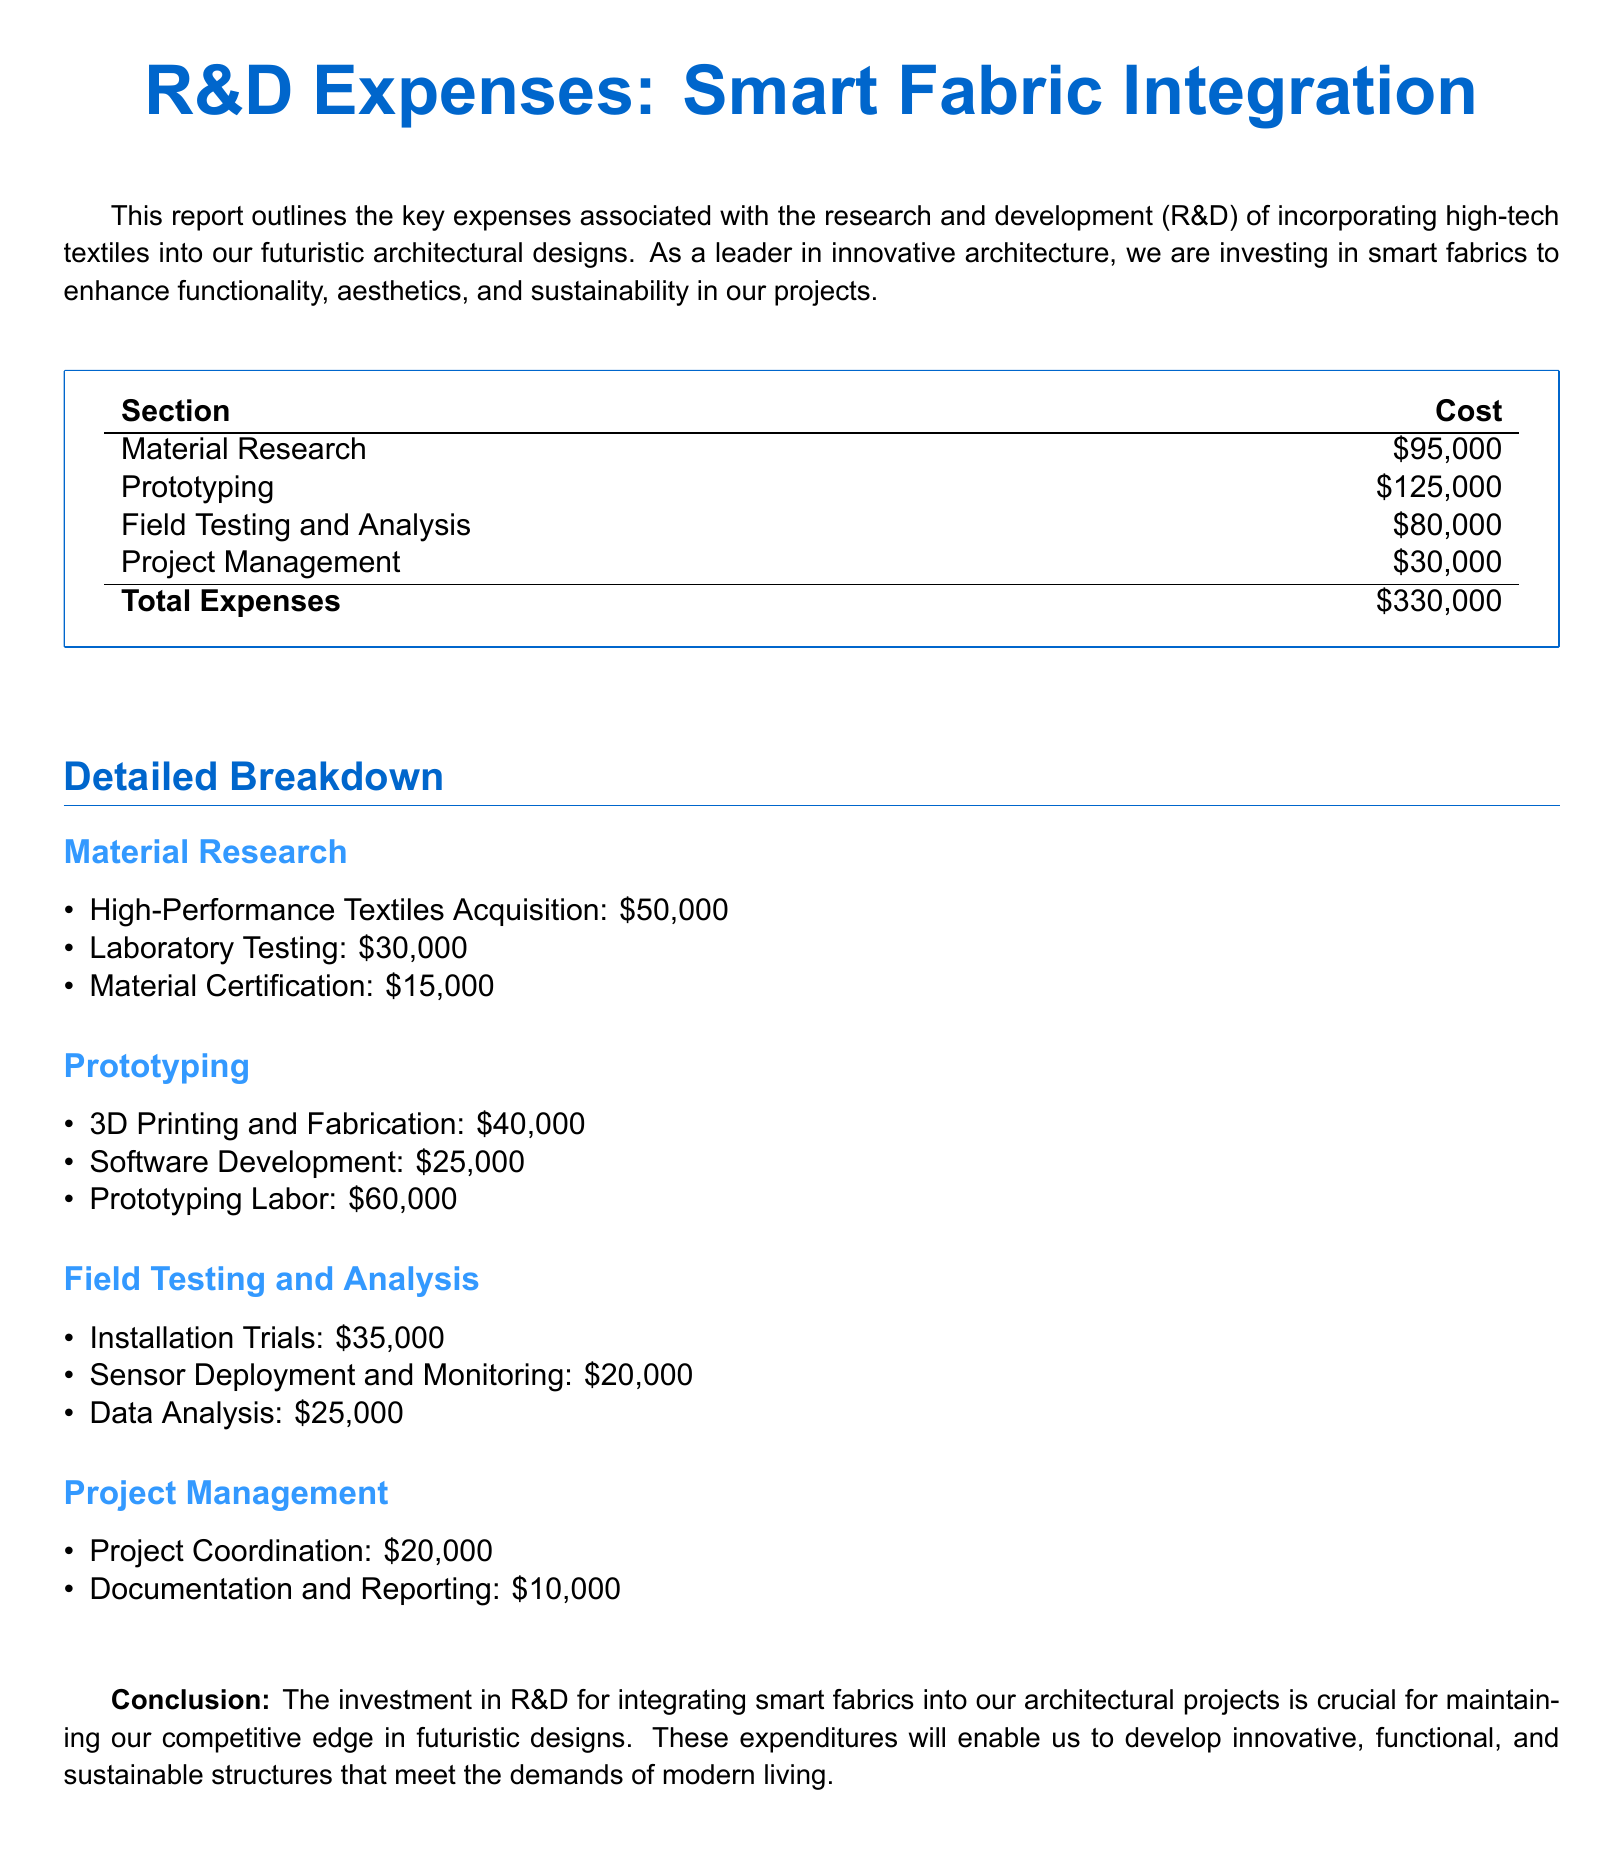What is the total amount invested in R&D expenses? The total R&D expenses are provided at the end of the expenses table in the document.
Answer: $330,000 How much was spent on Material Research? Material Research is a section in the expense report with its own total amount noted.
Answer: $95,000 What percentage of total expenses is attributed to Prototyping? Prototyping expenses can be calculated using the total expenses figure to determine the percentage it represents.
Answer: 37.88% What are the total costs for Field Testing and Analysis? The total costs for Field Testing and Analysis can be found in the breakdown of that specific section within the report.
Answer: $80,000 How much was allocated for Project Management? Project Management has a specific cost listed under the R&D expenses.
Answer: $30,000 What is the most expensive category of expenses in the report? By comparing the amounts listed in each category of the report, we can identify which is the highest.
Answer: Prototyping How much was spent on Sensor Deployment and Monitoring? This specific expense is listed under the Field Testing and Analysis section of the detailed breakdown.
Answer: $20,000 What is the sum of expenses for Laboratory Testing and Material Certification? Adding these two costs together provides the total for these specific expenses listed in the Material Research section.
Answer: $45,000 What is the cost for Documentation and Reporting in Project Management? The expense for Documentation and Reporting is specified in the Project Management breakdown.
Answer: $10,000 